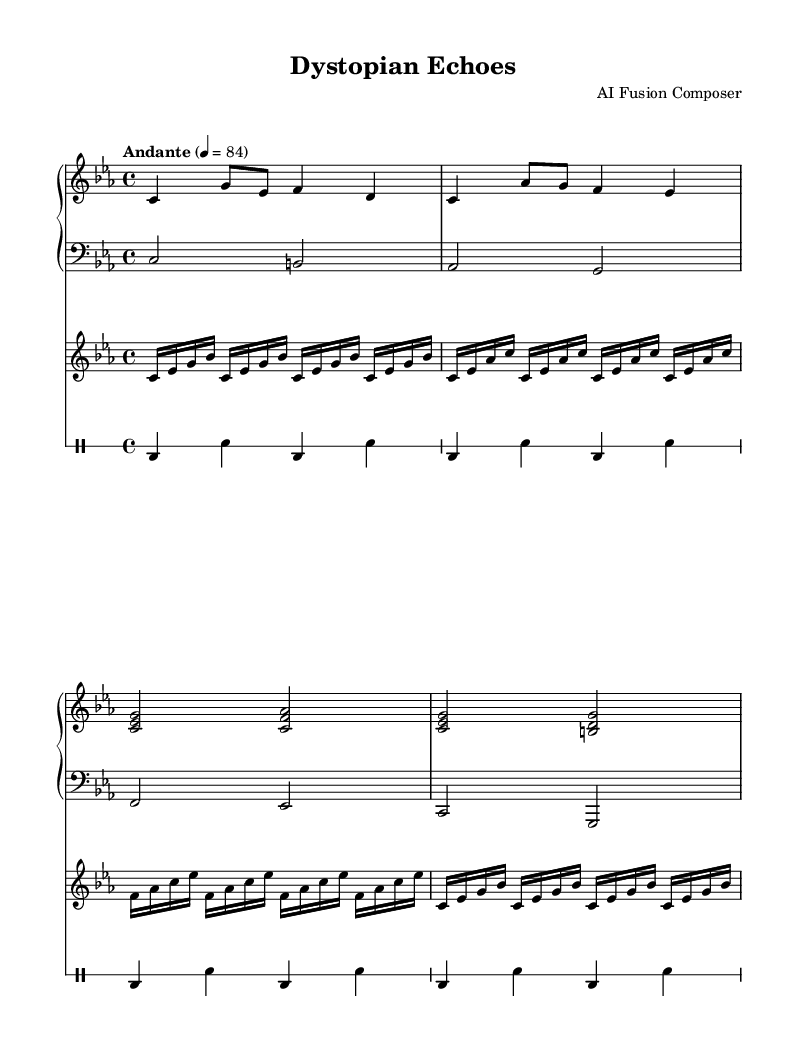What is the key signature of this music? The key signature shown in the global section indicates C minor, which has three flats (B♭, E♭, and A♭). This can be identified by looking at the key signature notation following the \key command.
Answer: C minor What is the time signature of this music? The time signature is indicated in the global section with the \time command, and it is set to 4/4. This means there are four beats per measure and a quarter note receives one beat.
Answer: 4/4 What is the tempo marking of this piece? The tempo marking is specified in the global section with the \tempo command, stating "Andante" at a speed of 84 beats per minute. This describes the intended pace of the music.
Answer: Andante 4 = 84 How many measures are in the piano part? By counting the measures in the piano section, one can determine that there are eight measures present. This can be evaluated by looking at the vertical lines which indicate the end of each measure.
Answer: 8 What musical instrument is used for the synthesizer part? The instrument used for the synthesizer part is specified in the \with clause, indicating "lead 2 (sawtooth)" which is a type of electronic synth sound suitable for fusion music.
Answer: lead 2 (sawtooth) How many different drum patterns are shown in the drum section? The drum patterns consist of repeating sequences, and there are four measures repeated four times, which results in a total of four unique measures in the provided drum section.
Answer: 4 What type of musical fusion is represented in this piece? This piece represents a fusion of classical piano and electronic beats, as indicated by the combination of traditional piano notation alongside synthesized sounds and drum patterns in the score.
Answer: Classical piano and electronic beats 